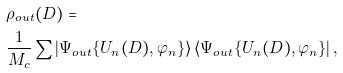Convert formula to latex. <formula><loc_0><loc_0><loc_500><loc_500>& \rho _ { o u t } ( D ) = \\ & \frac { 1 } { M _ { c } } \sum \left | \Psi _ { o u t } \{ U _ { n } ( D ) , \varphi _ { n } \} \right \rangle \left \langle \Psi _ { o u t } \{ U _ { n } ( D ) , \varphi _ { n } \} \right | ,</formula> 